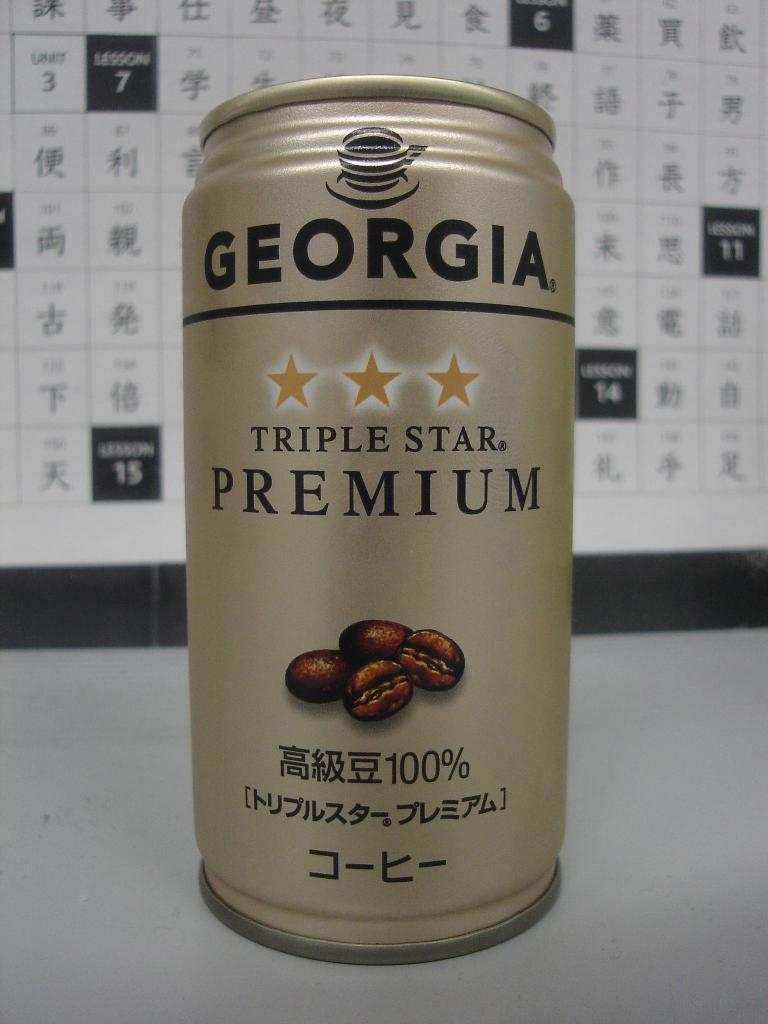<image>
Give a short and clear explanation of the subsequent image. A gold can of Georgia premium coffee on a table. 